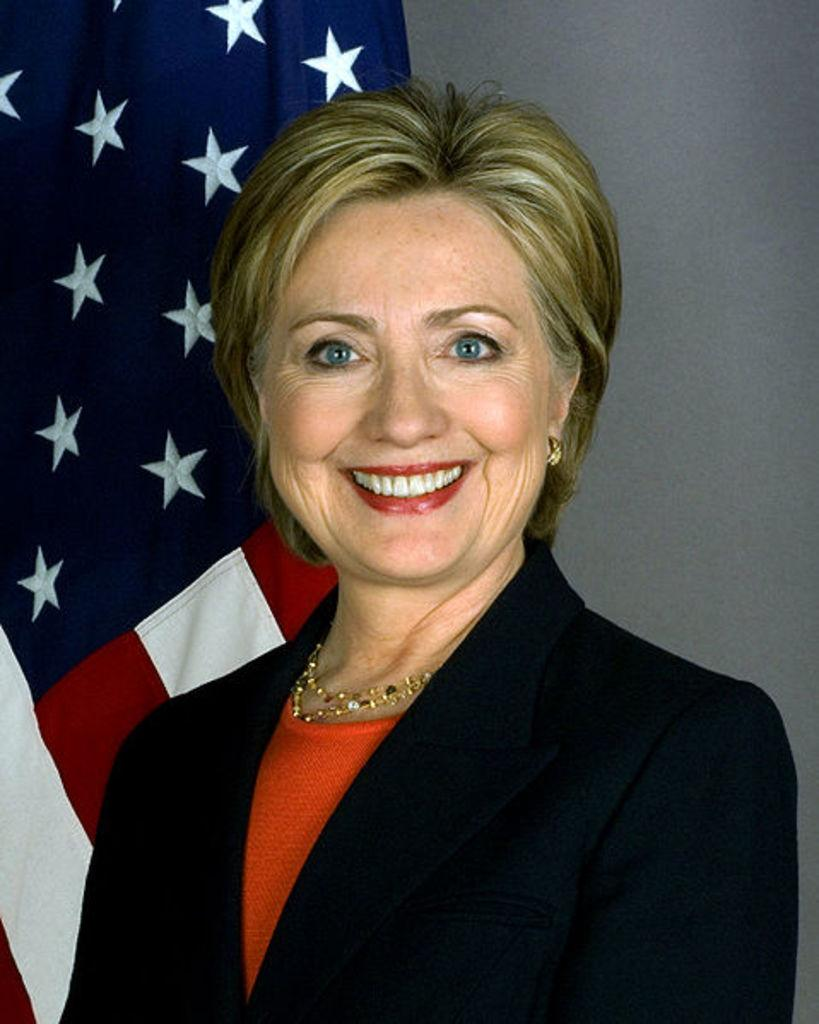What is the main subject of the image? The main subject of the image is a woman. What is the woman doing in the image? The woman is smiling in the image. What can be seen in the background of the image? There is a flag and a wall in the background of the image. Is the woman sleeping in the image? No, the woman is not sleeping in the image; she is smiling. What type of station is visible in the image? There is no station present in the image. 